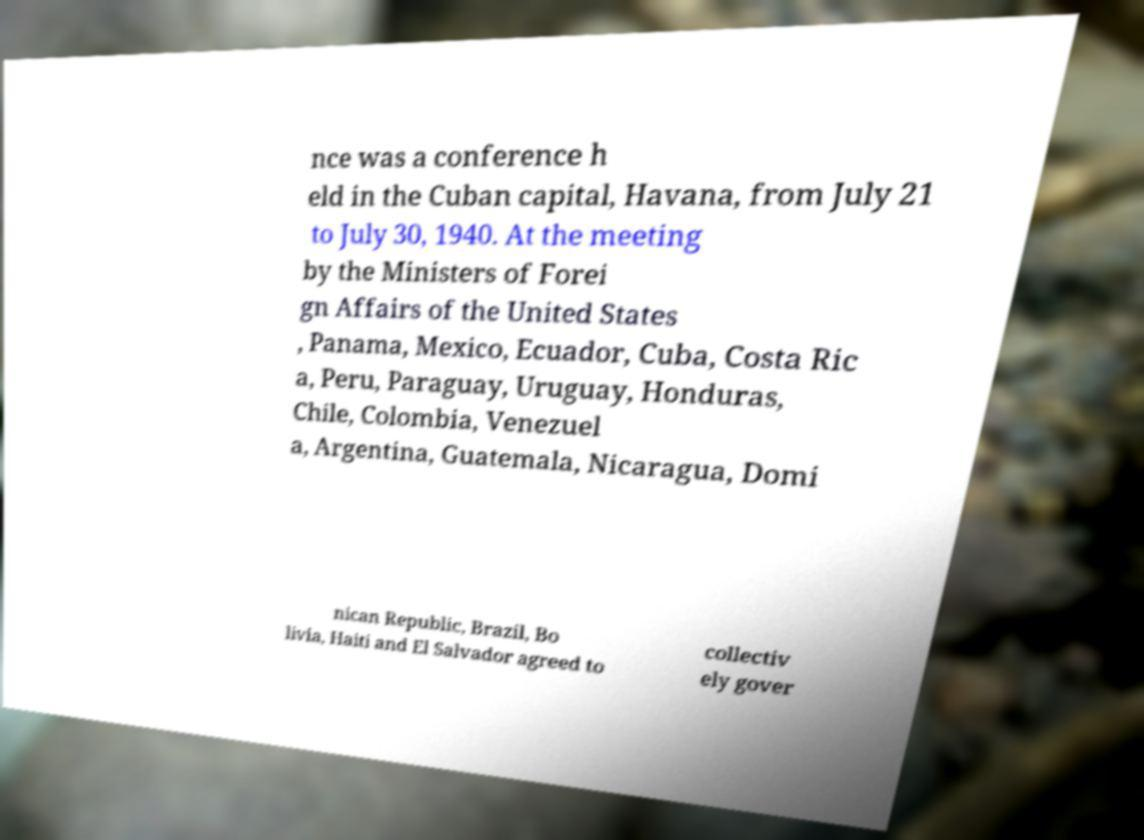Could you extract and type out the text from this image? nce was a conference h eld in the Cuban capital, Havana, from July 21 to July 30, 1940. At the meeting by the Ministers of Forei gn Affairs of the United States , Panama, Mexico, Ecuador, Cuba, Costa Ric a, Peru, Paraguay, Uruguay, Honduras, Chile, Colombia, Venezuel a, Argentina, Guatemala, Nicaragua, Domi nican Republic, Brazil, Bo livia, Haiti and El Salvador agreed to collectiv ely gover 